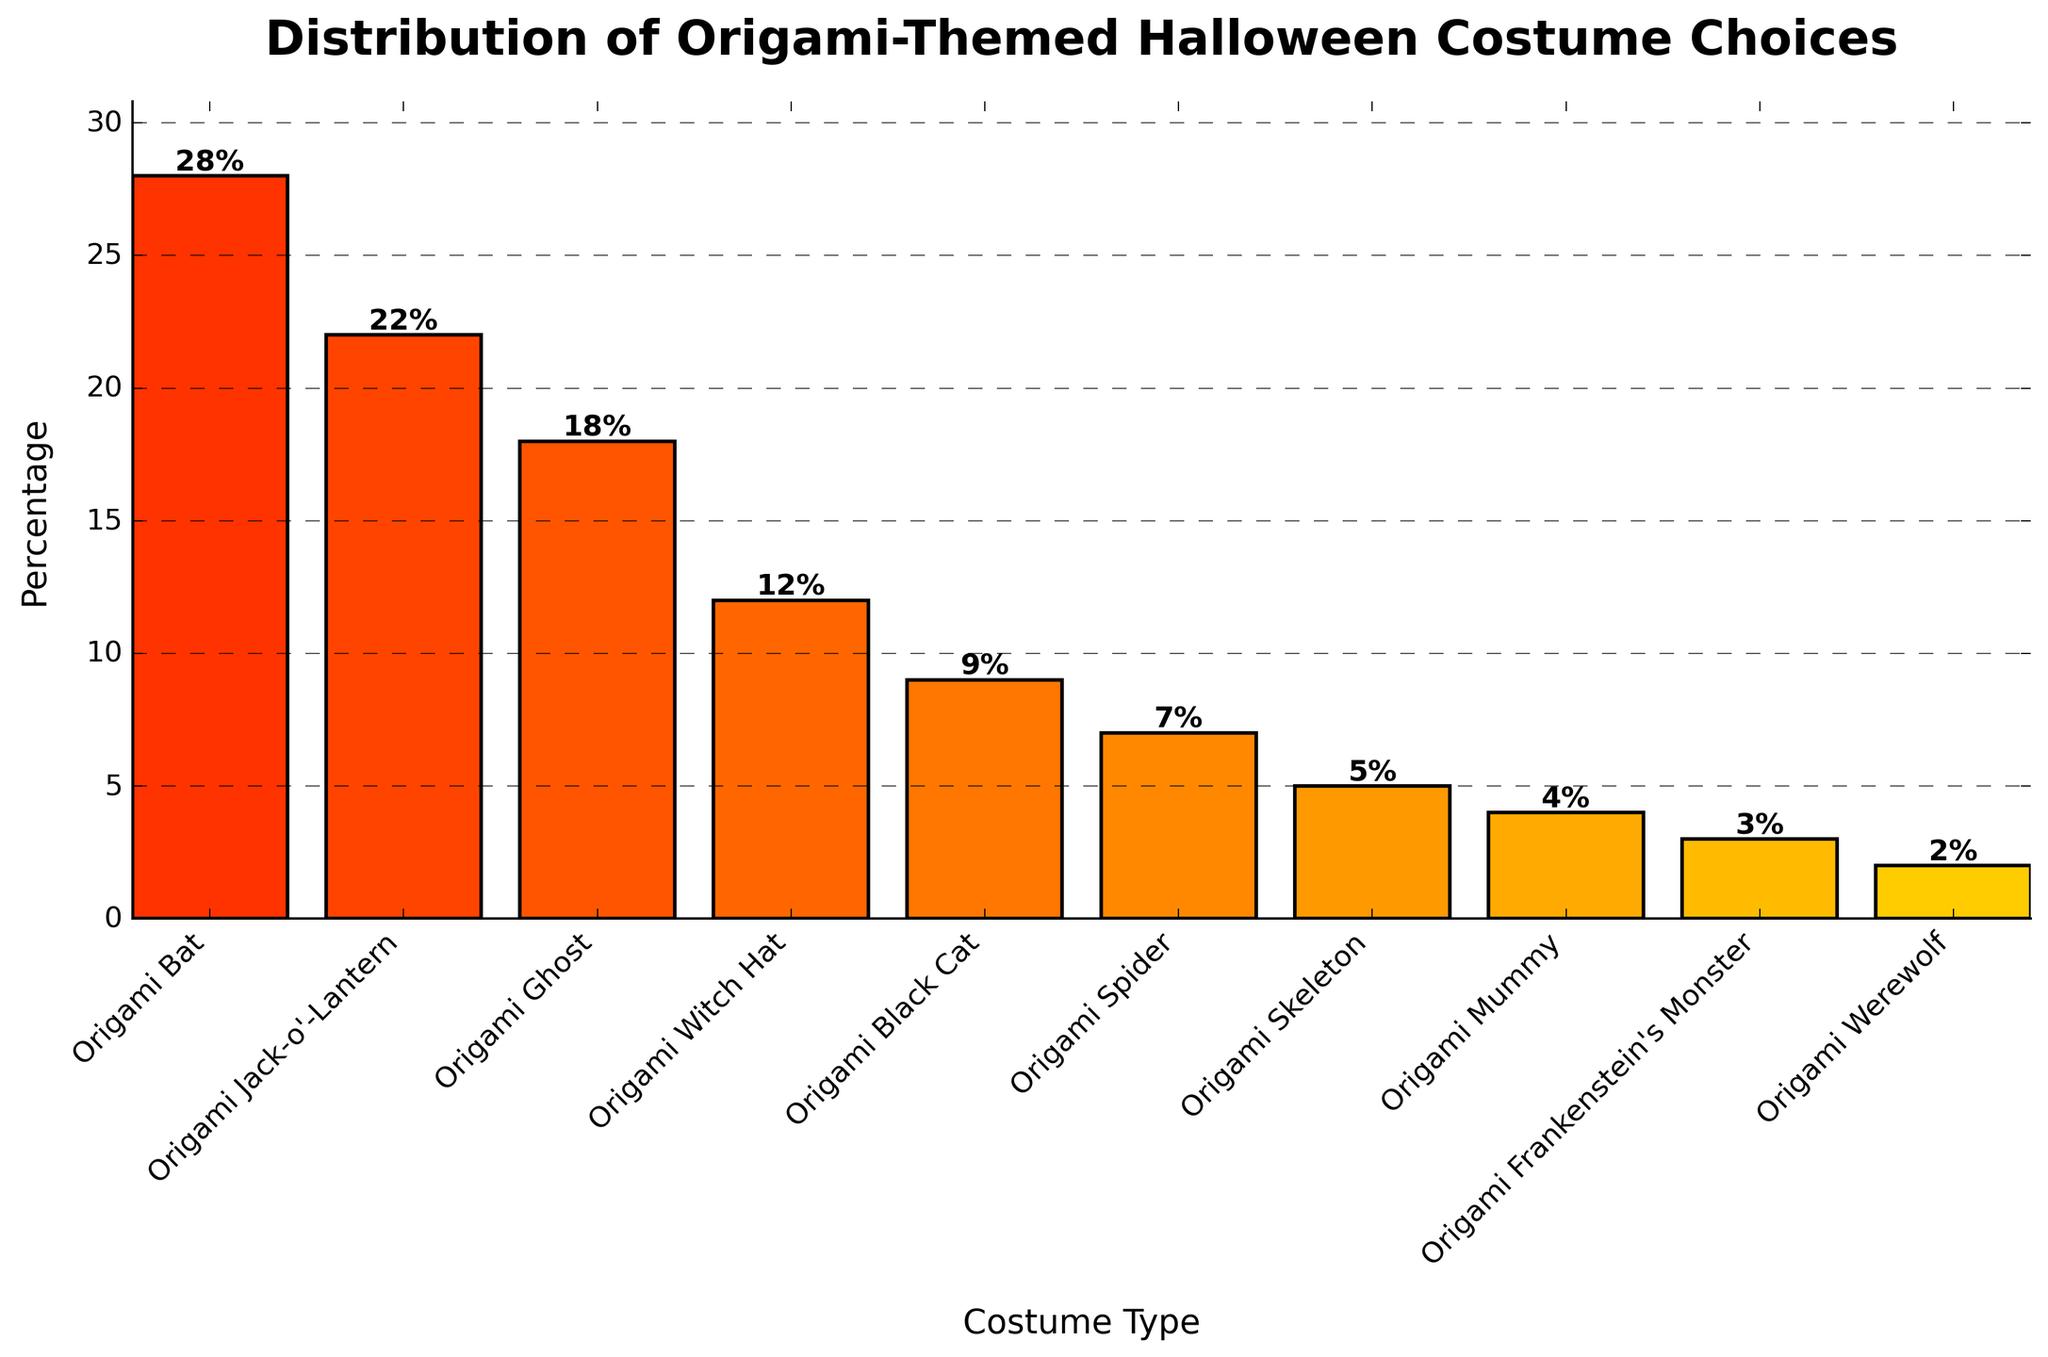What is the most popular origami-themed Halloween costume choice? The highest bar in the chart corresponds to the 'Origami Bat' with a percentage of 28%.
Answer: Origami Bat Which costume type has the lowest percentage? The smallest bar in the chart represents 'Origami Werewolf' with a percentage of 2%.
Answer: Origami Werewolf Are there more people choosing 'Origami Jack-o'-Lantern' or 'Origami Ghost'? The bar for 'Origami Jack-o'-Lantern' is higher with 22%, while 'Origami Ghost' has 18%. Thus, 'Origami Jack-o'-Lantern' is chosen more.
Answer: Origami Jack-o'-Lantern What's the combined percentage of people choosing 'Origami Witch Hat' and 'Origami Black Cat' costumes? 'Origami Witch Hat' has 12% and 'Origami Black Cat' has 9%. The combined percentage is 12 + 9 = 21%.
Answer: 21% Which groups have a percentage greater than 10%? The bars with heights greater than 10% are for 'Origami Bat' (28%), 'Origami Jack-o'-Lantern' (22%), 'Origami Ghost' (18%), and 'Origami Witch Hat' (12%).
Answer: Origami Bat, Origami Jack-o'-Lantern, Origami Ghost, Origami Witch Hat What is the average percentage of the top three costume choices? The top three costume choices are 'Origami Bat' (28%), 'Origami Jack-o'-Lantern' (22%), and 'Origami Ghost' (18%). Their average percentage is (28 + 22 + 18) / 3 = 22.67%.
Answer: 22.67% What's the difference in percentage between 'Origami Bat' and 'Origami Mummy'? 'Origami Bat' has 28% and 'Origami Mummy' has 4%. The difference is 28 - 4 = 24%.
Answer: 24% List the costume types with percentages in descending order. The percentages listed in descending order will give us: 'Origami Bat' (28%), 'Origami Jack-o'-Lantern' (22%), 'Origami Ghost' (18%), 'Origami Witch Hat' (12%), 'Origami Black Cat' (9%), 'Origami Spider' (7%), 'Origami Skeleton' (5%), 'Origami Mummy' (4%), 'Origami Frankenstein's Monster' (3%), 'Origami Werewolf' (2%).
Answer: Origami Bat, Origami Jack-o'-Lantern, Origami Ghost, Origami Witch Hat, Origami Black Cat, Origami Spider, Origami Skeleton, Origami Mummy, Origami Frankenstein's Monster, Origami Werewolf What is the combined percentage of all costume choices lower than 10%? Adding the percentages of costume choices lower than 10%: 9% (Origami Black Cat) + 7% (Origami Spider) + 5% (Origami Skeleton) + 4% (Origami Mummy) + 3% (Origami Frankenstein's Monster) + 2% (Origami Werewolf) = 30%
Answer: 30% 